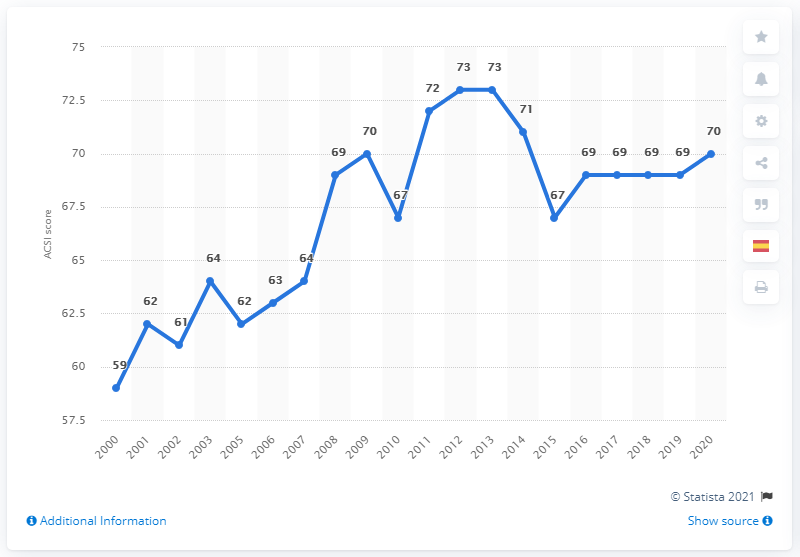Specify some key components in this picture. In 2020, McDonald's scored 70 on the American Customer Satisfaction Index (ACSI), indicating a moderate level of customer satisfaction. McDonald's restaurants in the United States had a customer satisfaction index score of 70 in 2020, according to data provided by the company. According to the American Customer Satisfaction Index scores for McDonald's restaurants in the United States for the 2019-2020 period, the average satisfaction level was 69.5 out of 100. 